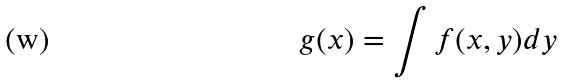Convert formula to latex. <formula><loc_0><loc_0><loc_500><loc_500>g ( x ) = \int f ( x , y ) d y</formula> 